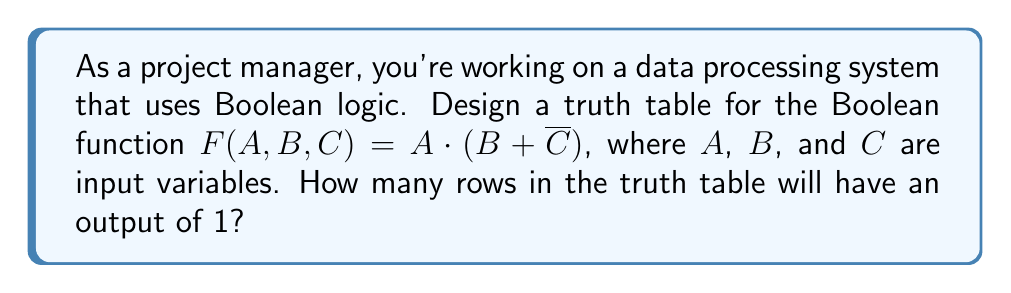Can you answer this question? To solve this problem, let's follow these steps:

1. Understand the Boolean function:
   $F(A,B,C) = A \cdot (B + \overline{C})$
   This means the output is 1 when A is 1 AND either B is 1 OR C is 0.

2. Create the truth table:
   - We have 3 input variables (A, B, C), so we'll have $2^3 = 8$ rows.
   - List all possible combinations of inputs.
   - Calculate the output for each combination.

   | A | B | C | B + $\overline{C}$ | F(A,B,C) |
   |---|---|---|-------------------|----------|
   | 0 | 0 | 0 |         1         |    0     |
   | 0 | 0 | 1 |         0         |    0     |
   | 0 | 1 | 0 |         1         |    0     |
   | 0 | 1 | 1 |         1         |    0     |
   | 1 | 0 | 0 |         1         |    1     |
   | 1 | 0 | 1 |         0         |    0     |
   | 1 | 1 | 0 |         1         |    1     |
   | 1 | 1 | 1 |         1         |    1     |

3. Count the number of rows where F(A,B,C) = 1:
   There are 3 rows where the output is 1.

Therefore, the truth table will have 3 rows with an output of 1.
Answer: 3 